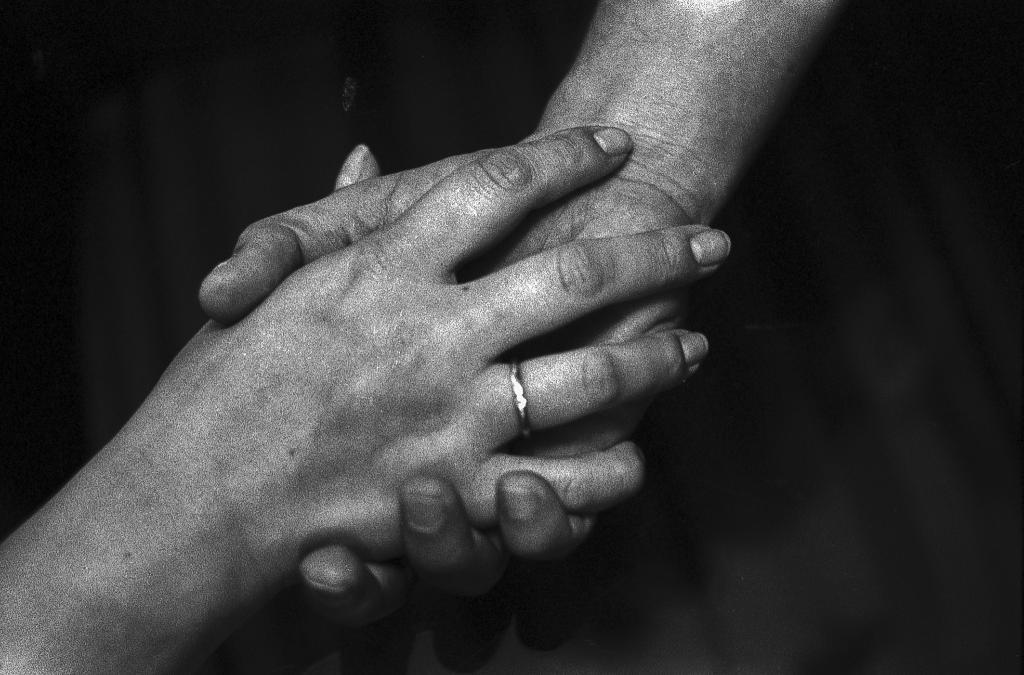What body part is visible in the image? There are hands visible in the image. What type of field can be seen in the image? There is no field present in the image; only hands are visible. What kind of airplane is flying in the image? There is no airplane present in the image; only hands are visible. 